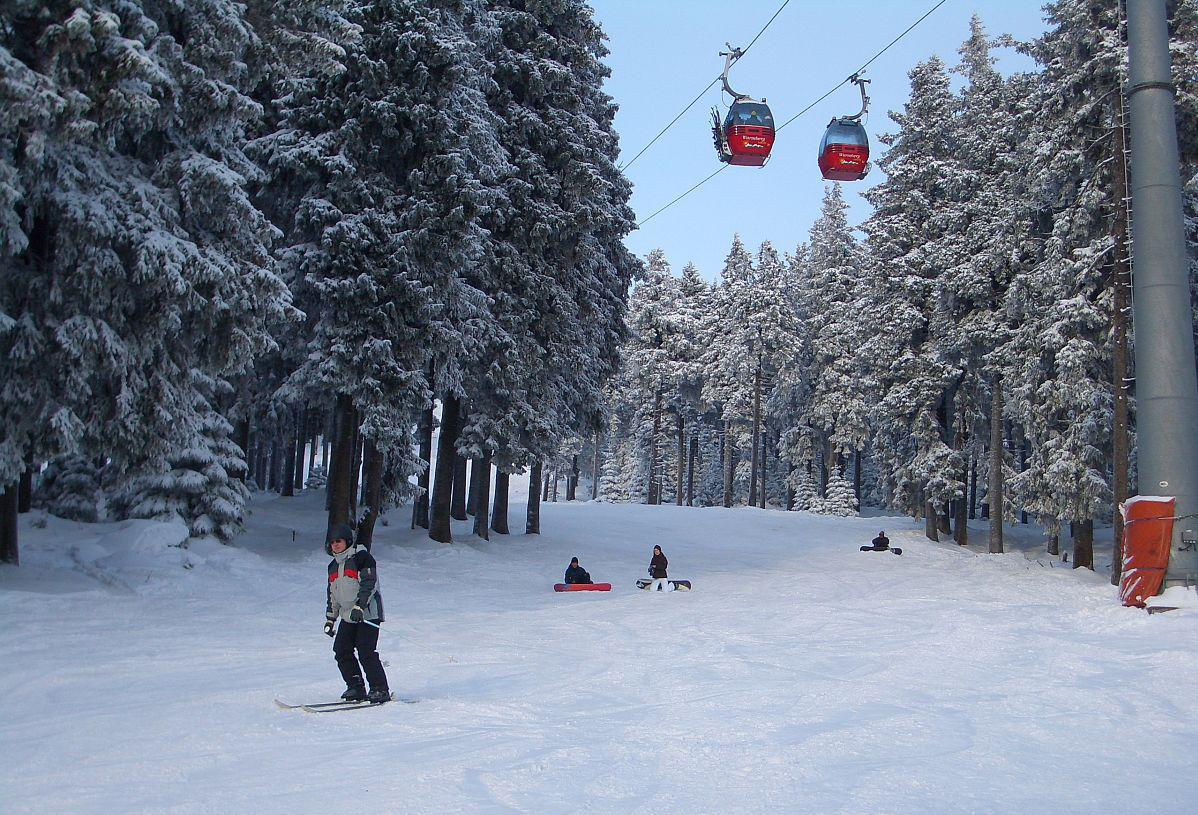Question: where was this picture taken?
Choices:
A. Outside.
B. Ski slope.
C. At a beach.
D. On a hiking trail.
Answer with the letter. Answer: B Question: why are the trees white?
Choices:
A. They are covered in show.
B. It snowed.
C. Because there is snow on the branches.
D. It's winter and they have snow.
Answer with the letter. Answer: B Question: what are the people doing?
Choices:
A. Playing frisbee in the park.
B. Swimming and laughing.
C. Skiing and sledding.
D. Watching a movie together.
Answer with the letter. Answer: C Question: what are the lines above for?
Choices:
A. Cable television.
B. Transport skiers.
C. Transmitting electricity.
D. Tightrope walkers.
Answer with the letter. Answer: B Question: what is the weather like?
Choices:
A. Clear and cold.
B. Warm and sunny.
C. Cloudy and chilly.
D. Rainy and thundering.
Answer with the letter. Answer: A Question: where are the ski-lifts?
Choices:
A. On the mountain.
B. Between rows of evergreens.
C. To the right in the photo.
D. Just outside the lodge.
Answer with the letter. Answer: B Question: where are the two red gondolas located?
Choices:
A. Across from each other.
B. On the cable.
C. In front of the building.
D. Next to the lodge.
Answer with the letter. Answer: A Question: who are enjoying the snow?
Choices:
A. The children.
B. Skiers.
C. The ski instructors.
D. The family.
Answer with the letter. Answer: B Question: who has fallen in the background?
Choices:
A. Lebron James.
B. An old person.
C. A deer.
D. A few skiers are on the ground.
Answer with the letter. Answer: D Question: why are the trees white?
Choices:
A. They are covered in ash.
B. They're decorated for Christmas.
C. They are covered in snow.
D. We painted them.
Answer with the letter. Answer: C Question: how is the man skiing dressed?
Choices:
A. Warmly.
B. Large coat and two pairs of pants.
C. Black pants and a grey jacket.
D. With a cool looking helmet.
Answer with the letter. Answer: C Question: what is the weather like outside?
Choices:
A. Hot.
B. Humid.
C. Snowy.
D. Rainy.
Answer with the letter. Answer: C Question: who has snowboards?
Choices:
A. Snowboarders.
B. The two boys.
C. Two people on ground.
D. The two girls.
Answer with the letter. Answer: C Question: what are mostly mature evergreens?
Choices:
A. The forest.
B. The woods.
C. The trees.
D. The pasture.
Answer with the letter. Answer: C Question: who is upright?
Choices:
A. One man.
B. One woman.
C. One person.
D. One boy.
Answer with the letter. Answer: C Question: what is daytime?
Choices:
A. The scene.
B. The image.
C. The photo.
D. The picture.
Answer with the letter. Answer: A Question: what is on the trees?
Choices:
A. Snow.
B. Leaves.
C. Branches.
D. Birds.
Answer with the letter. Answer: A Question: why are the people wearing jackets?
Choices:
A. To protect themselves from the cold.
B. To look cool.
C. They're comfortable.
D. To match.
Answer with the letter. Answer: A 